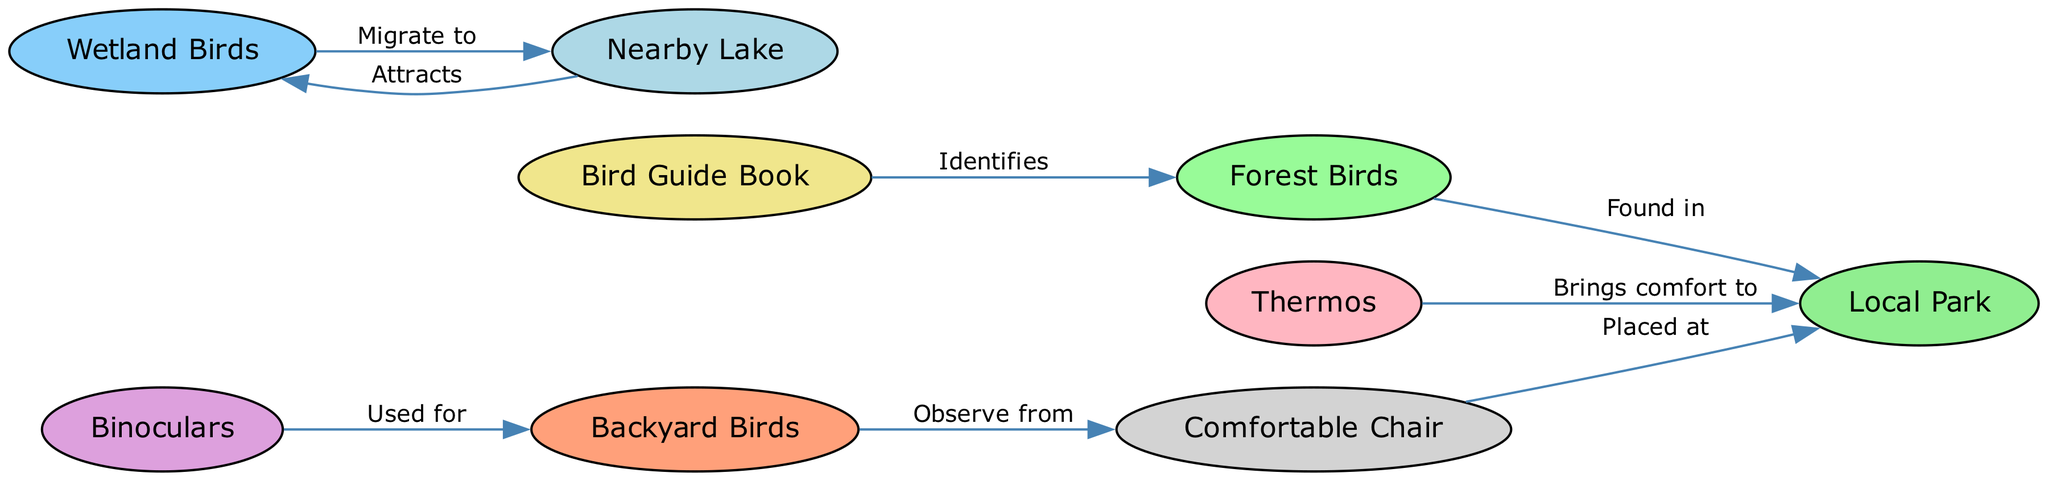What is the total number of nodes in the diagram? The diagram has a list of nodes which is counted. The nodes are Backyard Birds, Forest Birds, Wetland Birds, Binoculars, Bird Guide Book, Comfortable Chair, Thermos, Local Park, and Nearby Lake. Counting these gives a total of 9 nodes.
Answer: 9 Which birds can be observed from a Comfortable Chair? The edge leading from Comfortable Chair indicates the relationship to Backyard Birds. Therefore, it can be concluded that Backyard Birds can be observed from a Comfortable Chair.
Answer: Backyard Birds How many edges are there in total connecting the nodes? By counting the edges in the diagram, the relationships can be noted: 8 edges exist between the different nodes as per the data provided.
Answer: 8 Which location is indicated as attracting Wetland Birds? Following the edge from Nearby Lake tells us that it attracts Wetland Birds. Thus, the specific location attracting them is the Nearby Lake.
Answer: Nearby Lake What is the purpose of using Binoculars? The directed edge from Binoculars to Backyard Birds explicitly states that Binoculars are used for observing Backyard Birds. Hence, the purpose is clear.
Answer: Observe Backyard Birds In which location can Forest Birds be found? The diagram states that Forest Birds have a directed edge leading to Local Park, indicating that Forest Birds can be found in this location.
Answer: Local Park What items are shown to bring comfort to the Local Park? The Thermos is connected to Local Park indicating that it brings comfort there. While the Comfortable Chair is also connected to Local Park, it does not explicitly denote 'comfort.' Hence, answering solely based on the provided connections leads us to Thermos.
Answer: Thermos Which bird species is identified by the Bird Guide Book? The edge from Bird Guide Book indicates that it specifically identifies Forest Birds. Therefore, the answer is Forest Birds.
Answer: Forest Birds How does a Nearby Lake relate to Wetland Birds? The relation is established through the directed edge which indicates Nearby Lake attracts Wetland Birds. This shows a direct migratory relationship as well.
Answer: Attracts Wetland Birds 